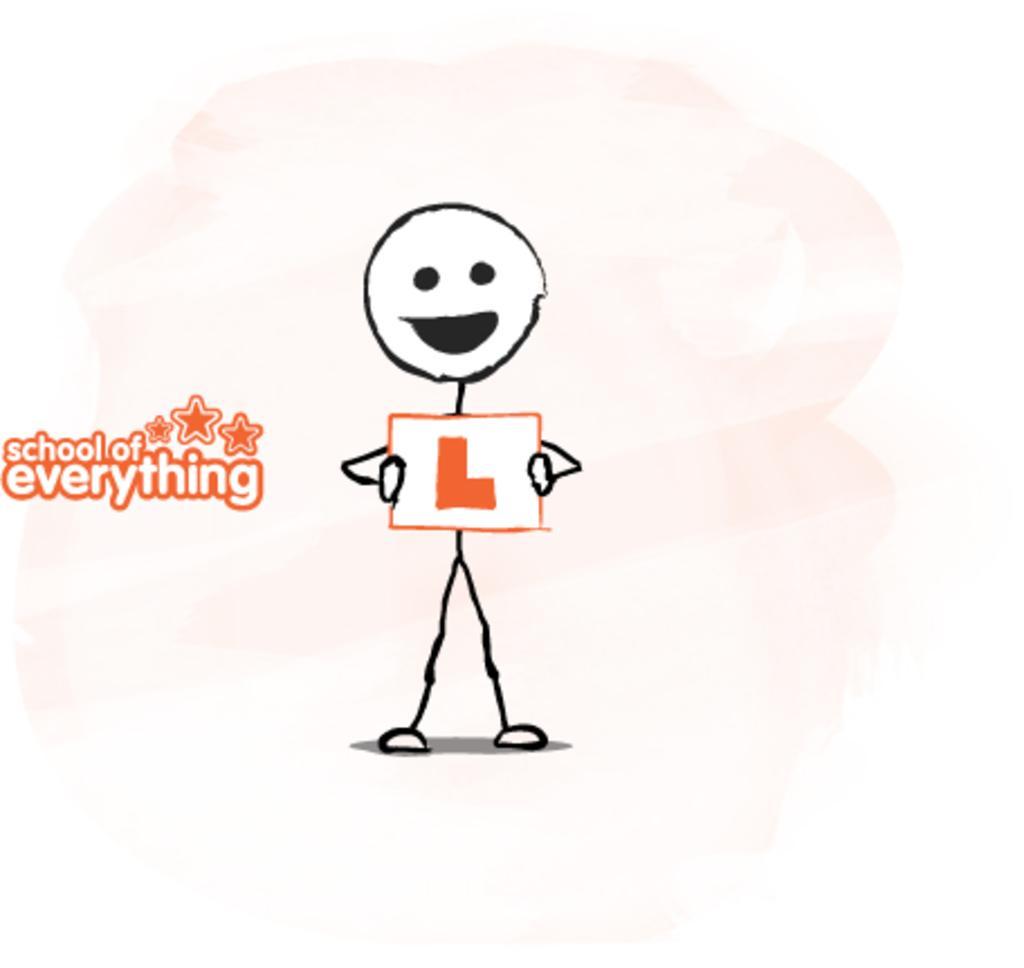In one or two sentences, can you explain what this image depicts? In this image we can see a person clipart and some text on it. 